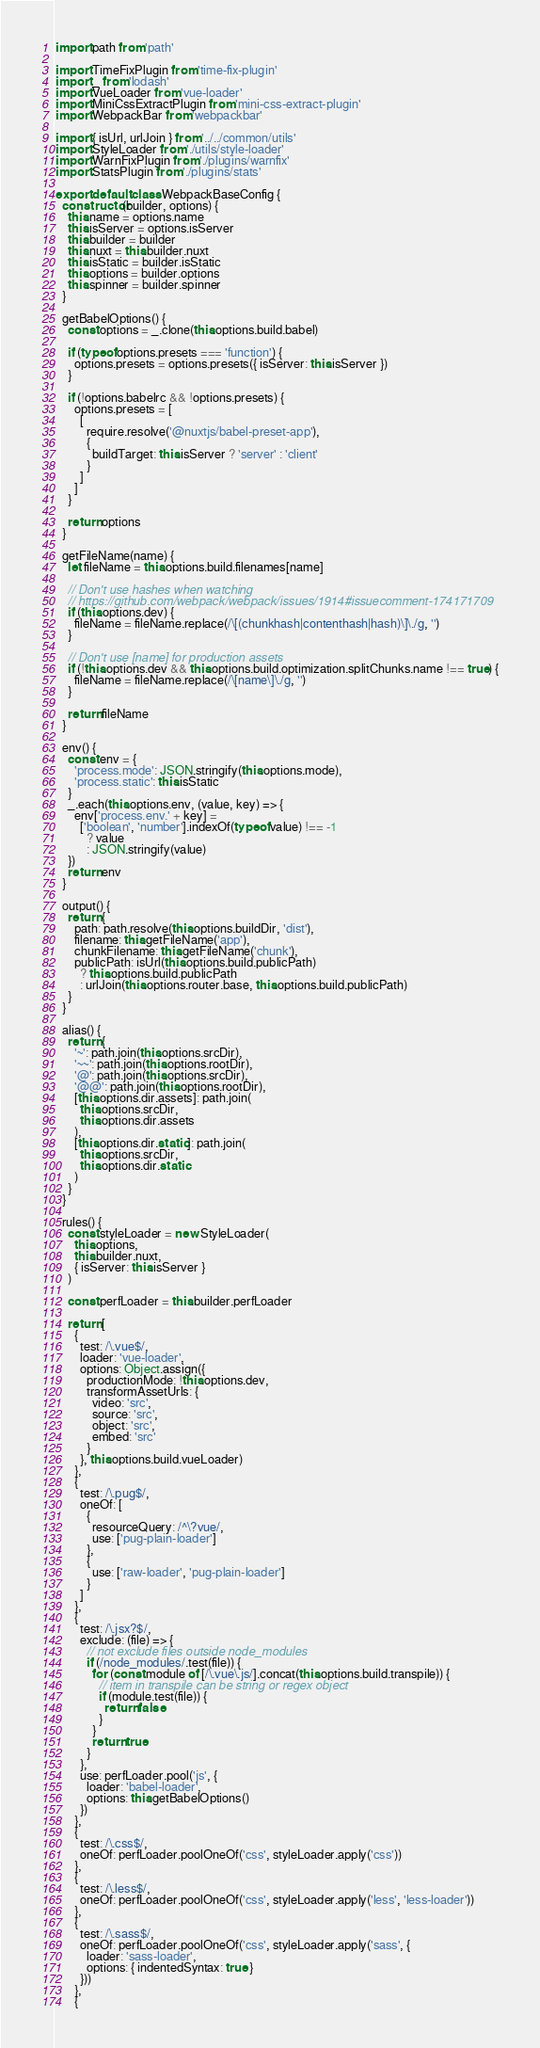Convert code to text. <code><loc_0><loc_0><loc_500><loc_500><_JavaScript_>import path from 'path'

import TimeFixPlugin from 'time-fix-plugin'
import _ from 'lodash'
import VueLoader from 'vue-loader'
import MiniCssExtractPlugin from 'mini-css-extract-plugin'
import WebpackBar from 'webpackbar'

import { isUrl, urlJoin } from '../../common/utils'
import StyleLoader from './utils/style-loader'
import WarnFixPlugin from './plugins/warnfix'
import StatsPlugin from './plugins/stats'

export default class WebpackBaseConfig {
  constructor(builder, options) {
    this.name = options.name
    this.isServer = options.isServer
    this.builder = builder
    this.nuxt = this.builder.nuxt
    this.isStatic = builder.isStatic
    this.options = builder.options
    this.spinner = builder.spinner
  }

  getBabelOptions() {
    const options = _.clone(this.options.build.babel)

    if (typeof options.presets === 'function') {
      options.presets = options.presets({ isServer: this.isServer })
    }

    if (!options.babelrc && !options.presets) {
      options.presets = [
        [
          require.resolve('@nuxtjs/babel-preset-app'),
          {
            buildTarget: this.isServer ? 'server' : 'client'
          }
        ]
      ]
    }

    return options
  }

  getFileName(name) {
    let fileName = this.options.build.filenames[name]

    // Don't use hashes when watching
    // https://github.com/webpack/webpack/issues/1914#issuecomment-174171709
    if (this.options.dev) {
      fileName = fileName.replace(/\[(chunkhash|contenthash|hash)\]\./g, '')
    }

    // Don't use [name] for production assets
    if (!this.options.dev && this.options.build.optimization.splitChunks.name !== true) {
      fileName = fileName.replace(/\[name\]\./g, '')
    }

    return fileName
  }

  env() {
    const env = {
      'process.mode': JSON.stringify(this.options.mode),
      'process.static': this.isStatic
    }
    _.each(this.options.env, (value, key) => {
      env['process.env.' + key] =
        ['boolean', 'number'].indexOf(typeof value) !== -1
          ? value
          : JSON.stringify(value)
    })
    return env
  }

  output() {
    return {
      path: path.resolve(this.options.buildDir, 'dist'),
      filename: this.getFileName('app'),
      chunkFilename: this.getFileName('chunk'),
      publicPath: isUrl(this.options.build.publicPath)
        ? this.options.build.publicPath
        : urlJoin(this.options.router.base, this.options.build.publicPath)
    }
  }

  alias() {
    return {
      '~': path.join(this.options.srcDir),
      '~~': path.join(this.options.rootDir),
      '@': path.join(this.options.srcDir),
      '@@': path.join(this.options.rootDir),
      [this.options.dir.assets]: path.join(
        this.options.srcDir,
        this.options.dir.assets
      ),
      [this.options.dir.static]: path.join(
        this.options.srcDir,
        this.options.dir.static
      )
    }
  }

  rules() {
    const styleLoader = new StyleLoader(
      this.options,
      this.builder.nuxt,
      { isServer: this.isServer }
    )

    const perfLoader = this.builder.perfLoader

    return [
      {
        test: /\.vue$/,
        loader: 'vue-loader',
        options: Object.assign({
          productionMode: !this.options.dev,
          transformAssetUrls: {
            video: 'src',
            source: 'src',
            object: 'src',
            embed: 'src'
          }
        }, this.options.build.vueLoader)
      },
      {
        test: /\.pug$/,
        oneOf: [
          {
            resourceQuery: /^\?vue/,
            use: ['pug-plain-loader']
          },
          {
            use: ['raw-loader', 'pug-plain-loader']
          }
        ]
      },
      {
        test: /\.jsx?$/,
        exclude: (file) => {
          // not exclude files outside node_modules
          if (/node_modules/.test(file)) {
            for (const module of [/\.vue\.js/].concat(this.options.build.transpile)) {
              // item in transpile can be string or regex object
              if (module.test(file)) {
                return false
              }
            }
            return true
          }
        },
        use: perfLoader.pool('js', {
          loader: 'babel-loader',
          options: this.getBabelOptions()
        })
      },
      {
        test: /\.css$/,
        oneOf: perfLoader.poolOneOf('css', styleLoader.apply('css'))
      },
      {
        test: /\.less$/,
        oneOf: perfLoader.poolOneOf('css', styleLoader.apply('less', 'less-loader'))
      },
      {
        test: /\.sass$/,
        oneOf: perfLoader.poolOneOf('css', styleLoader.apply('sass', {
          loader: 'sass-loader',
          options: { indentedSyntax: true }
        }))
      },
      {</code> 